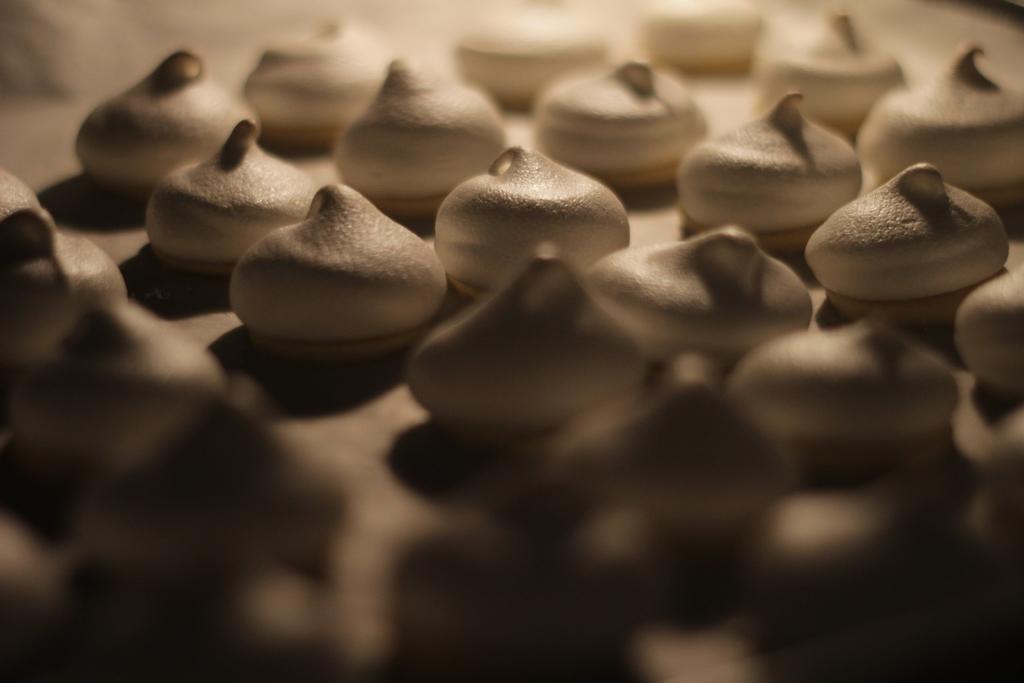How would you summarize this image in a sentence or two? In this picture we can see an object containing the food items. 